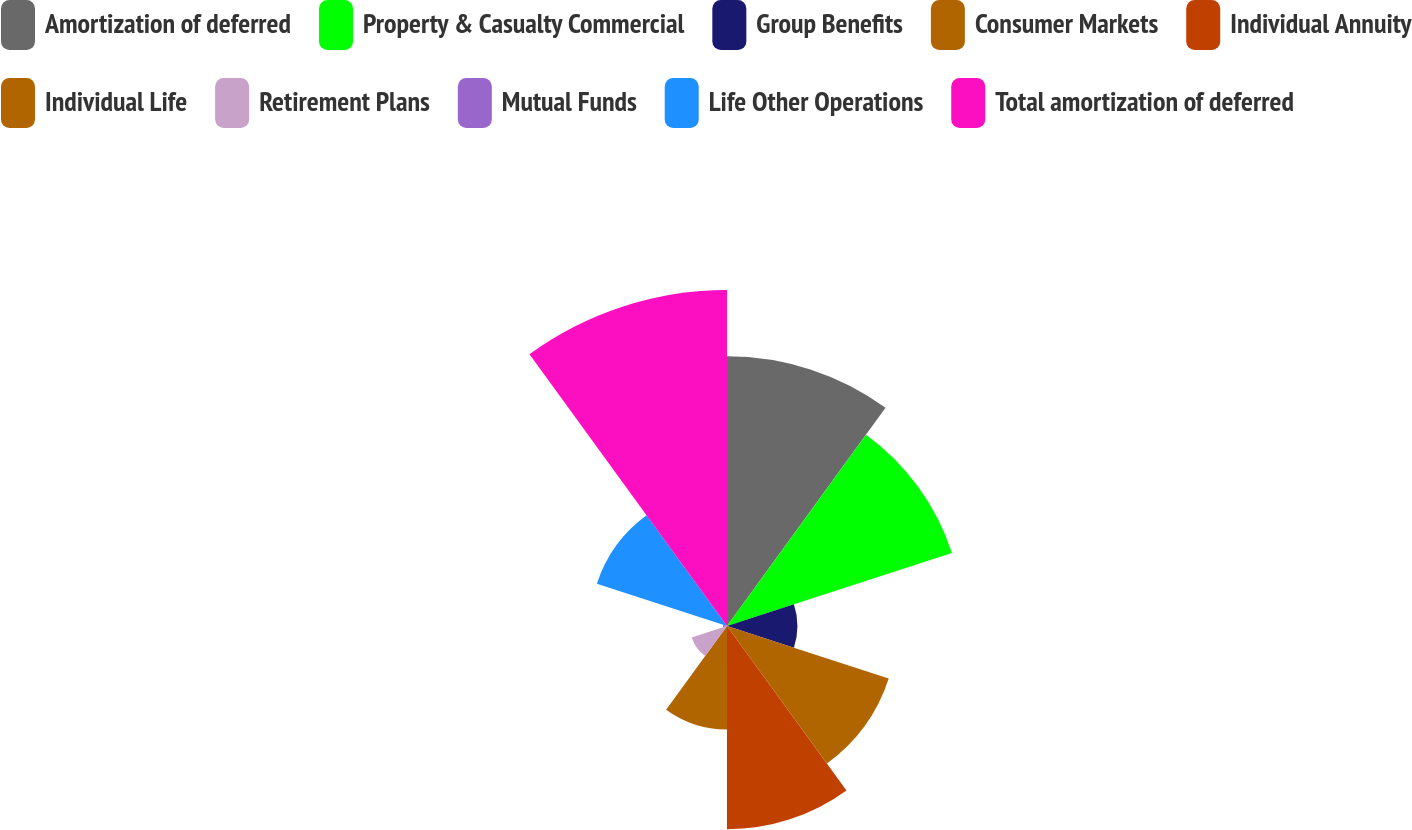Convert chart to OTSL. <chart><loc_0><loc_0><loc_500><loc_500><pie_chart><fcel>Amortization of deferred<fcel>Property & Casualty Commercial<fcel>Group Benefits<fcel>Consumer Markets<fcel>Individual Annuity<fcel>Individual Life<fcel>Retirement Plans<fcel>Mutual Funds<fcel>Life Other Operations<fcel>Total amortization of deferred<nl><fcel>17.21%<fcel>15.09%<fcel>4.49%<fcel>10.85%<fcel>12.97%<fcel>6.61%<fcel>2.37%<fcel>0.25%<fcel>8.73%<fcel>21.44%<nl></chart> 